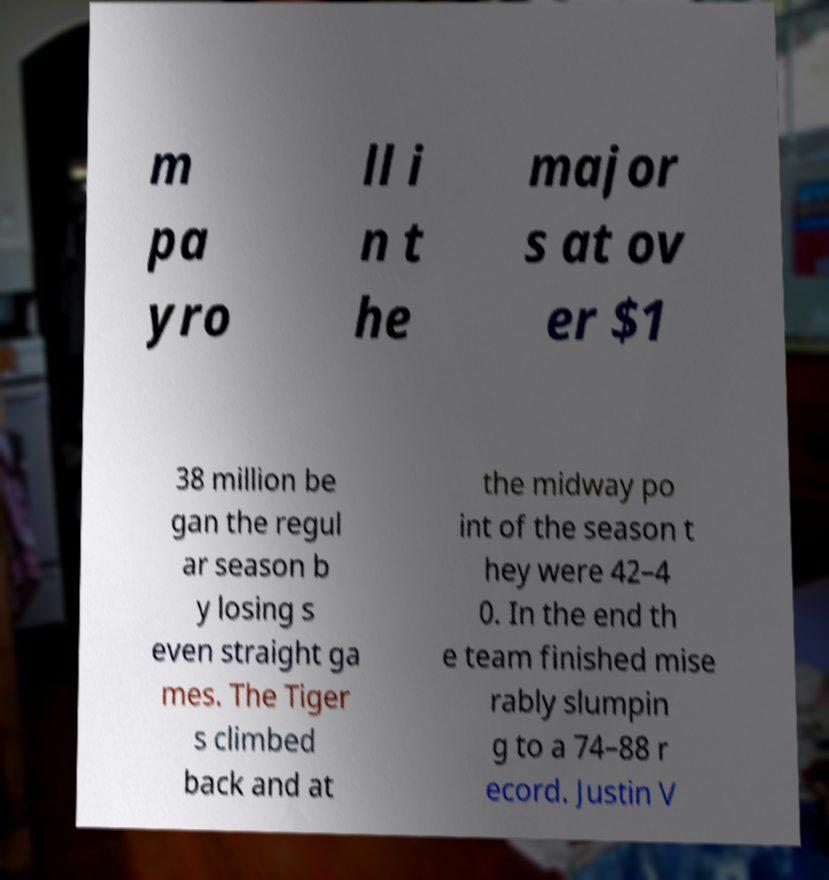Can you read and provide the text displayed in the image?This photo seems to have some interesting text. Can you extract and type it out for me? m pa yro ll i n t he major s at ov er $1 38 million be gan the regul ar season b y losing s even straight ga mes. The Tiger s climbed back and at the midway po int of the season t hey were 42–4 0. In the end th e team finished mise rably slumpin g to a 74–88 r ecord. Justin V 